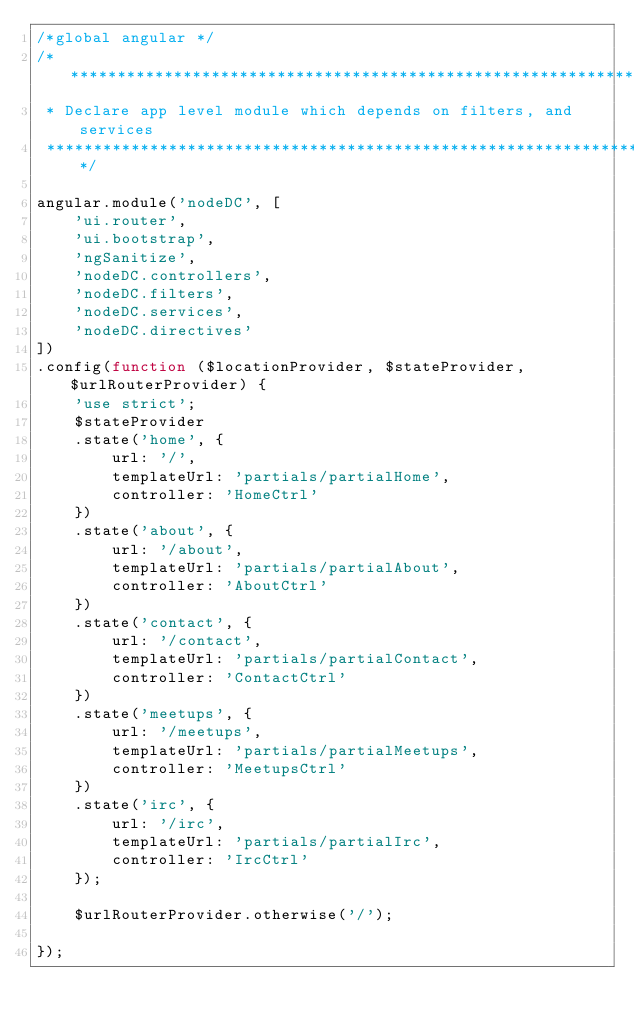Convert code to text. <code><loc_0><loc_0><loc_500><loc_500><_JavaScript_>/*global angular */
/*******************************************************************************
 * Declare app level module which depends on filters, and services
 ******************************************************************************/

angular.module('nodeDC', [
    'ui.router',
    'ui.bootstrap',
    'ngSanitize',
    'nodeDC.controllers',
    'nodeDC.filters',
    'nodeDC.services',
    'nodeDC.directives'
])
.config(function ($locationProvider, $stateProvider, $urlRouterProvider) {
    'use strict';
    $stateProvider
    .state('home', {
        url: '/',
        templateUrl: 'partials/partialHome',
        controller: 'HomeCtrl'
    })
    .state('about', {
        url: '/about',
        templateUrl: 'partials/partialAbout',
        controller: 'AboutCtrl'
    })
    .state('contact', {
        url: '/contact',
        templateUrl: 'partials/partialContact',
        controller: 'ContactCtrl'
    })
    .state('meetups', {
        url: '/meetups',
        templateUrl: 'partials/partialMeetups',
        controller: 'MeetupsCtrl'
    })
    .state('irc', {
        url: '/irc',
        templateUrl: 'partials/partialIrc',
        controller: 'IrcCtrl'
    });

    $urlRouterProvider.otherwise('/');

});
</code> 